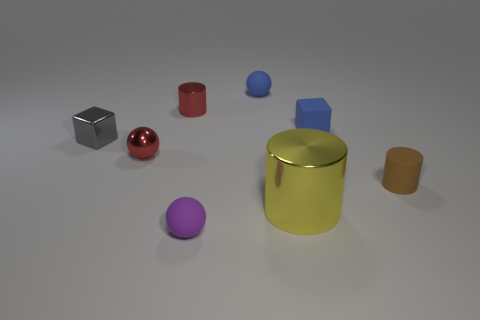Are there any cyan cylinders?
Your answer should be very brief. No. There is a metallic object right of the tiny red metal cylinder left of the small blue cube; how big is it?
Keep it short and to the point. Large. There is a small block right of the small blue ball; does it have the same color as the matte sphere behind the rubber cylinder?
Offer a terse response. Yes. The rubber object that is behind the gray metallic block and in front of the blue matte sphere is what color?
Your answer should be very brief. Blue. What number of other things are there of the same shape as the large yellow shiny thing?
Keep it short and to the point. 2. The metallic cube that is the same size as the metal sphere is what color?
Keep it short and to the point. Gray. What is the color of the small rubber ball that is in front of the red sphere?
Offer a terse response. Purple. Is there a small metal sphere left of the ball that is to the left of the tiny purple rubber object?
Your response must be concise. No. There is a large metallic object; is its shape the same as the blue thing on the left side of the small blue matte cube?
Give a very brief answer. No. There is a thing that is both right of the tiny gray cube and to the left of the red cylinder; what size is it?
Your answer should be very brief. Small. 